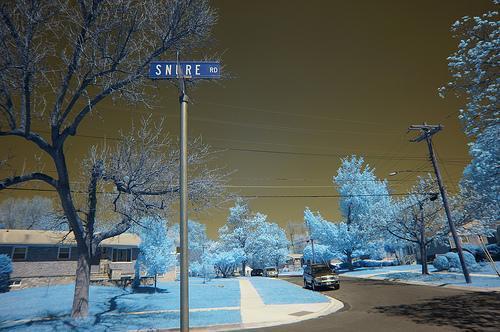How many vehicles are in the picture?
Give a very brief answer. 3. 